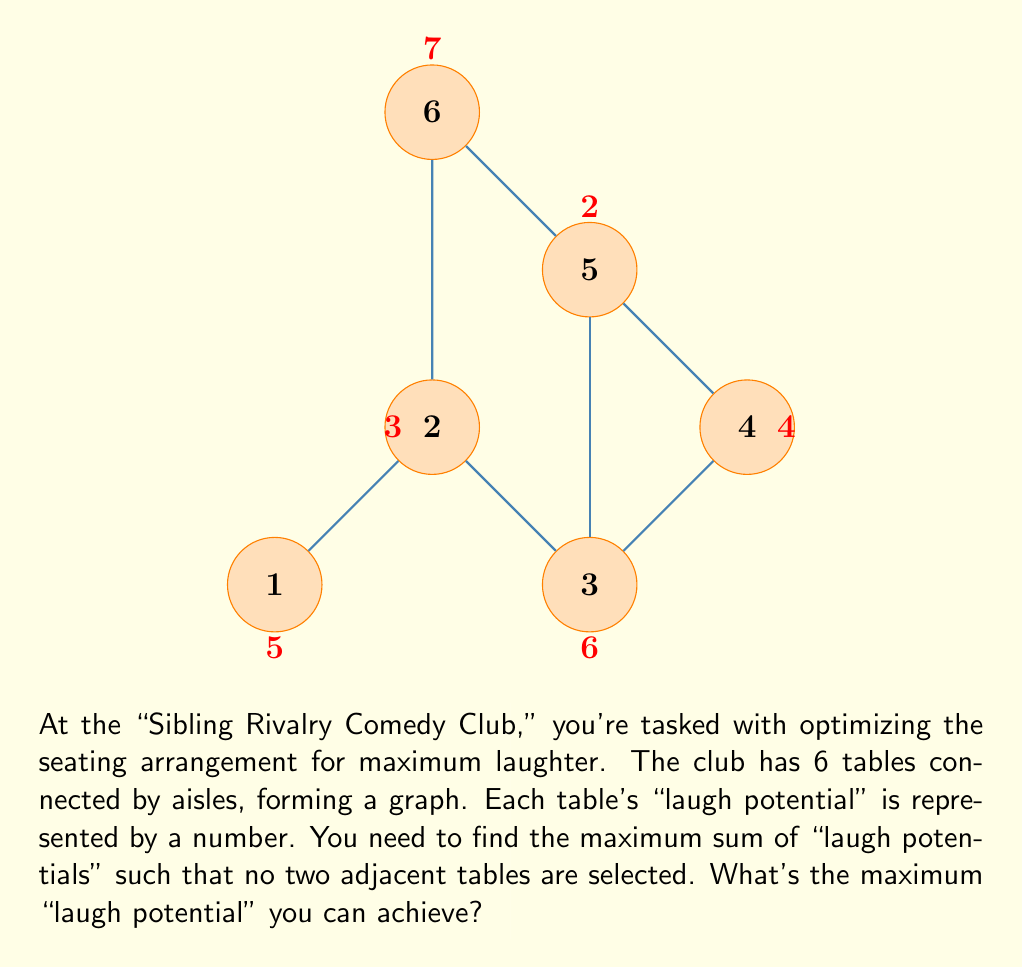Can you answer this question? To solve this problem, we can use dynamic programming, specifically the concept of independent set in graph theory. Here's a step-by-step solution:

1) First, let's number the tables from 1 to 6 as shown in the diagram.

2) We'll create an array $dp$ where $dp[i]$ represents the maximum "laugh potential" that can be achieved considering tables 1 to $i$.

3) Initialize the array:
   $dp[1] = 5$ (we can always select the first table)
   $dp[2] = \max(5, 3) = 5$ (we can either select table 1 or 2, but not both)

4) For the remaining tables, we have two choices:
   a) Include the current table and the best arrangement two steps back
   b) Exclude the current table and take the best arrangement one step back

5) This gives us the recurrence relation:
   $dp[i] = \max(dp[i-1], dp[i-2] + \text{laugh_potential}[i])$

6) Let's calculate:
   $dp[3] = \max(5, 5 + 6) = 11$
   $dp[4] = \max(11, 5 + 4) = 11$
   $dp[5] = \max(11, 11 + 2) = 13$
   $dp[6] = \max(13, 11 + 7) = 18$

7) The maximum "laugh potential" is the last element of our $dp$ array, which is 18.

8) To determine which tables were selected, we can backtrack:
   - 18 came from including table 6 (7) and $dp[4]$ (11)
   - 11 came from including table 3 (6) and $dp[1]$ (5)

Therefore, the optimal selection is tables 1, 3, and 6.
Answer: 18 